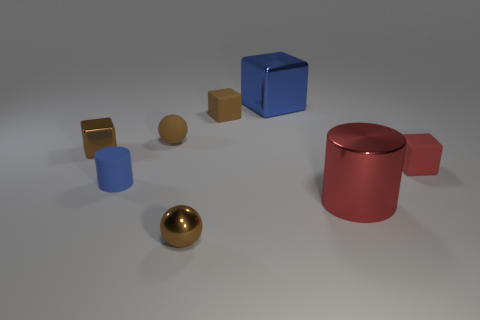There is a shiny object that is on the right side of the matte cylinder and behind the red cube; what is its color?
Your answer should be compact. Blue. What number of other objects are there of the same shape as the tiny red thing?
Ensure brevity in your answer.  3. There is a small object that is in front of the large red shiny thing; is its color the same as the tiny metal thing to the left of the blue rubber cylinder?
Your answer should be very brief. Yes. There is a blue object that is in front of the big cube; is it the same size as the cylinder that is on the right side of the tiny blue thing?
Offer a terse response. No. There is a tiny sphere behind the cube that is to the right of the red thing in front of the tiny red rubber object; what is it made of?
Offer a terse response. Rubber. Do the big red object and the blue rubber object have the same shape?
Ensure brevity in your answer.  Yes. There is a tiny red object that is the same shape as the large blue shiny thing; what material is it?
Give a very brief answer. Rubber. What number of small rubber blocks are the same color as the small metallic block?
Keep it short and to the point. 1. What is the size of the blue object that is made of the same material as the big cylinder?
Offer a terse response. Large. How many purple things are either big spheres or tiny matte cubes?
Provide a short and direct response. 0. 